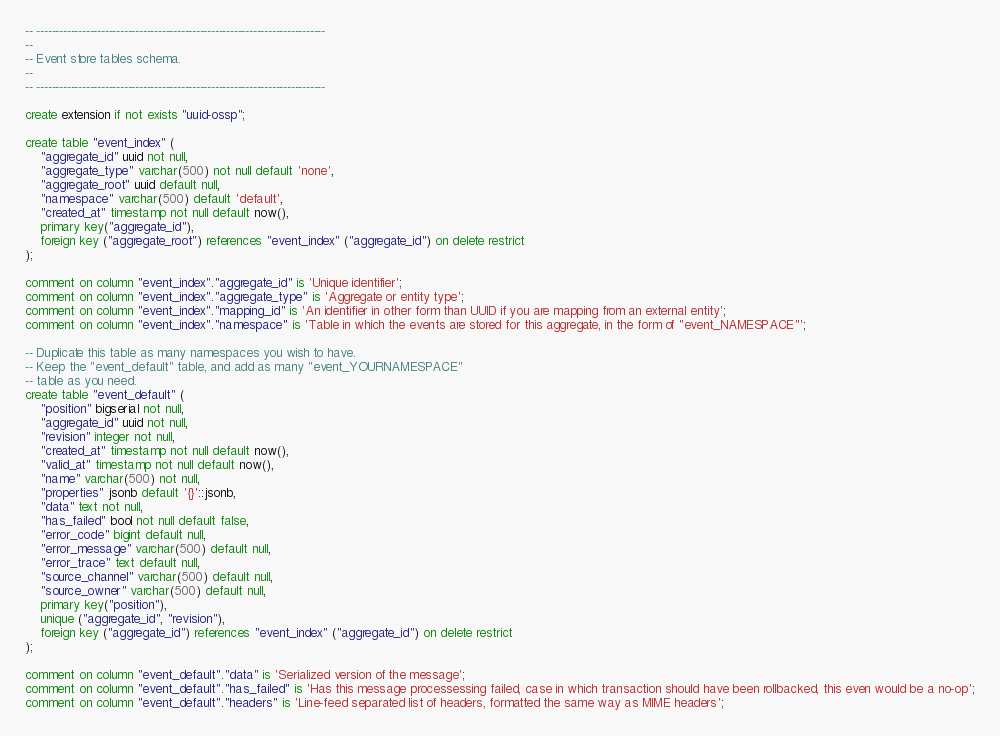Convert code to text. <code><loc_0><loc_0><loc_500><loc_500><_SQL_>
-- ----------------------------------------------------------------------------
--
-- Event store tables schema.
--
-- ----------------------------------------------------------------------------

create extension if not exists "uuid-ossp";

create table "event_index" (
    "aggregate_id" uuid not null,
    "aggregate_type" varchar(500) not null default 'none',
    "aggregate_root" uuid default null,
    "namespace" varchar(500) default 'default',
    "created_at" timestamp not null default now(),
    primary key("aggregate_id"),
    foreign key ("aggregate_root") references "event_index" ("aggregate_id") on delete restrict
);

comment on column "event_index"."aggregate_id" is 'Unique identifier';
comment on column "event_index"."aggregate_type" is 'Aggregate or entity type';
comment on column "event_index"."mapping_id" is 'An identifier in other form than UUID if you are mapping from an external entity';
comment on column "event_index"."namespace" is 'Table in which the events are stored for this aggregate, in the form of "event_NAMESPACE"';

-- Duplicate this table as many namespaces you wish to have.
-- Keep the "event_default" table, and add as many "event_YOURNAMESPACE"
-- table as you need.
create table "event_default" (
    "position" bigserial not null,
    "aggregate_id" uuid not null,
    "revision" integer not null,
    "created_at" timestamp not null default now(),
    "valid_at" timestamp not null default now(),
    "name" varchar(500) not null,
    "properties" jsonb default '{}'::jsonb,
    "data" text not null,
    "has_failed" bool not null default false,
    "error_code" bigint default null,
    "error_message" varchar(500) default null,
    "error_trace" text default null,
    "source_channel" varchar(500) default null,
    "source_owner" varchar(500) default null,
    primary key("position"),
    unique ("aggregate_id", "revision"),
    foreign key ("aggregate_id") references "event_index" ("aggregate_id") on delete restrict
);

comment on column "event_default"."data" is 'Serialized version of the message';
comment on column "event_default"."has_failed" is 'Has this message processessing failed, case in which transaction should have been rollbacked, this even would be a no-op';
comment on column "event_default"."headers" is 'Line-feed separated list of headers, formatted the same way as MIME headers';</code> 